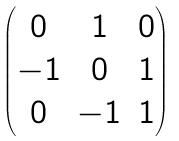<formula> <loc_0><loc_0><loc_500><loc_500>\begin{pmatrix} 0 & 1 & 0 \\ - 1 & 0 & 1 \\ 0 & - 1 & 1 \end{pmatrix}</formula> 